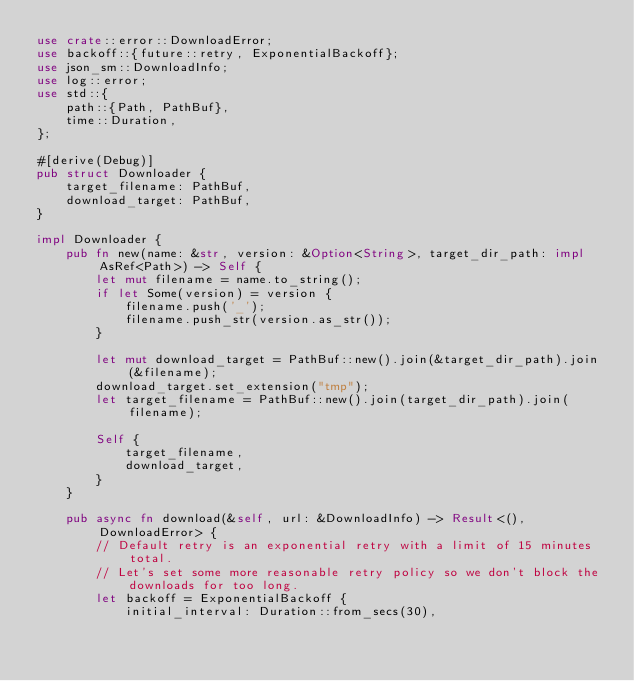Convert code to text. <code><loc_0><loc_0><loc_500><loc_500><_Rust_>use crate::error::DownloadError;
use backoff::{future::retry, ExponentialBackoff};
use json_sm::DownloadInfo;
use log::error;
use std::{
    path::{Path, PathBuf},
    time::Duration,
};

#[derive(Debug)]
pub struct Downloader {
    target_filename: PathBuf,
    download_target: PathBuf,
}

impl Downloader {
    pub fn new(name: &str, version: &Option<String>, target_dir_path: impl AsRef<Path>) -> Self {
        let mut filename = name.to_string();
        if let Some(version) = version {
            filename.push('_');
            filename.push_str(version.as_str());
        }

        let mut download_target = PathBuf::new().join(&target_dir_path).join(&filename);
        download_target.set_extension("tmp");
        let target_filename = PathBuf::new().join(target_dir_path).join(filename);

        Self {
            target_filename,
            download_target,
        }
    }

    pub async fn download(&self, url: &DownloadInfo) -> Result<(), DownloadError> {
        // Default retry is an exponential retry with a limit of 15 minutes total.
        // Let's set some more reasonable retry policy so we don't block the downloads for too long.
        let backoff = ExponentialBackoff {
            initial_interval: Duration::from_secs(30),</code> 